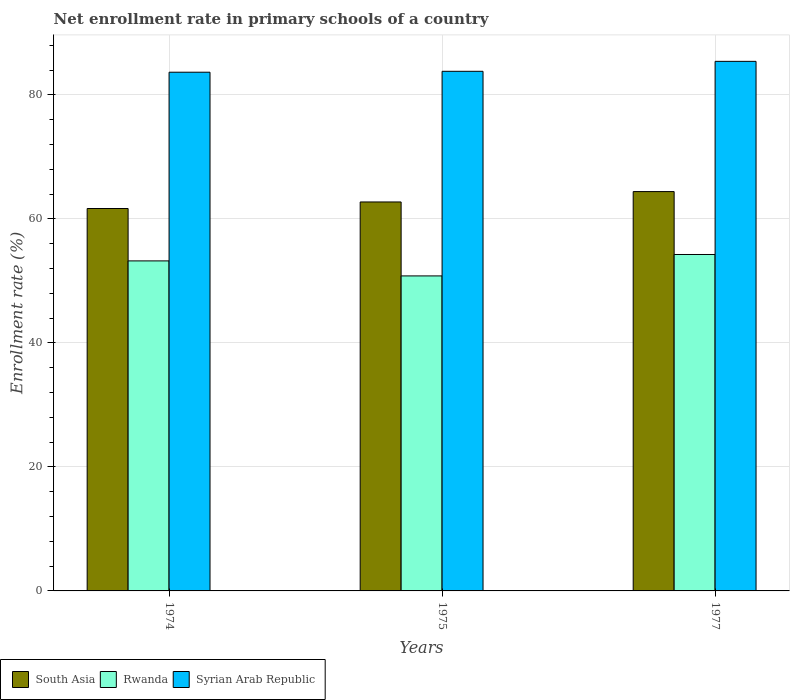How many groups of bars are there?
Offer a very short reply. 3. What is the label of the 2nd group of bars from the left?
Provide a short and direct response. 1975. In how many cases, is the number of bars for a given year not equal to the number of legend labels?
Ensure brevity in your answer.  0. What is the enrollment rate in primary schools in Syrian Arab Republic in 1974?
Your answer should be compact. 83.67. Across all years, what is the maximum enrollment rate in primary schools in Syrian Arab Republic?
Offer a terse response. 85.42. Across all years, what is the minimum enrollment rate in primary schools in Syrian Arab Republic?
Provide a succinct answer. 83.67. In which year was the enrollment rate in primary schools in Syrian Arab Republic minimum?
Your answer should be compact. 1974. What is the total enrollment rate in primary schools in Syrian Arab Republic in the graph?
Your response must be concise. 252.92. What is the difference between the enrollment rate in primary schools in Rwanda in 1974 and that in 1977?
Keep it short and to the point. -1.03. What is the difference between the enrollment rate in primary schools in South Asia in 1975 and the enrollment rate in primary schools in Syrian Arab Republic in 1974?
Offer a terse response. -20.93. What is the average enrollment rate in primary schools in South Asia per year?
Offer a very short reply. 62.95. In the year 1974, what is the difference between the enrollment rate in primary schools in Syrian Arab Republic and enrollment rate in primary schools in South Asia?
Offer a terse response. 21.99. What is the ratio of the enrollment rate in primary schools in Syrian Arab Republic in 1975 to that in 1977?
Provide a short and direct response. 0.98. Is the enrollment rate in primary schools in South Asia in 1974 less than that in 1977?
Give a very brief answer. Yes. What is the difference between the highest and the second highest enrollment rate in primary schools in South Asia?
Offer a very short reply. 1.67. What is the difference between the highest and the lowest enrollment rate in primary schools in Rwanda?
Make the answer very short. 3.46. Is the sum of the enrollment rate in primary schools in South Asia in 1974 and 1977 greater than the maximum enrollment rate in primary schools in Rwanda across all years?
Your answer should be compact. Yes. What does the 2nd bar from the left in 1977 represents?
Offer a very short reply. Rwanda. What does the 3rd bar from the right in 1975 represents?
Make the answer very short. South Asia. Is it the case that in every year, the sum of the enrollment rate in primary schools in South Asia and enrollment rate in primary schools in Rwanda is greater than the enrollment rate in primary schools in Syrian Arab Republic?
Give a very brief answer. Yes. Are all the bars in the graph horizontal?
Your answer should be very brief. No. How many years are there in the graph?
Keep it short and to the point. 3. Are the values on the major ticks of Y-axis written in scientific E-notation?
Offer a terse response. No. Does the graph contain grids?
Keep it short and to the point. Yes. Where does the legend appear in the graph?
Provide a succinct answer. Bottom left. How many legend labels are there?
Offer a terse response. 3. How are the legend labels stacked?
Your answer should be compact. Horizontal. What is the title of the graph?
Keep it short and to the point. Net enrollment rate in primary schools of a country. Does "Turkmenistan" appear as one of the legend labels in the graph?
Your response must be concise. No. What is the label or title of the X-axis?
Keep it short and to the point. Years. What is the label or title of the Y-axis?
Ensure brevity in your answer.  Enrollment rate (%). What is the Enrollment rate (%) in South Asia in 1974?
Your answer should be compact. 61.69. What is the Enrollment rate (%) in Rwanda in 1974?
Offer a terse response. 53.24. What is the Enrollment rate (%) of Syrian Arab Republic in 1974?
Ensure brevity in your answer.  83.67. What is the Enrollment rate (%) of South Asia in 1975?
Keep it short and to the point. 62.74. What is the Enrollment rate (%) in Rwanda in 1975?
Provide a succinct answer. 50.81. What is the Enrollment rate (%) in Syrian Arab Republic in 1975?
Keep it short and to the point. 83.82. What is the Enrollment rate (%) of South Asia in 1977?
Offer a very short reply. 64.42. What is the Enrollment rate (%) in Rwanda in 1977?
Give a very brief answer. 54.27. What is the Enrollment rate (%) of Syrian Arab Republic in 1977?
Provide a short and direct response. 85.42. Across all years, what is the maximum Enrollment rate (%) in South Asia?
Your answer should be compact. 64.42. Across all years, what is the maximum Enrollment rate (%) in Rwanda?
Offer a very short reply. 54.27. Across all years, what is the maximum Enrollment rate (%) of Syrian Arab Republic?
Your answer should be compact. 85.42. Across all years, what is the minimum Enrollment rate (%) in South Asia?
Your response must be concise. 61.69. Across all years, what is the minimum Enrollment rate (%) of Rwanda?
Keep it short and to the point. 50.81. Across all years, what is the minimum Enrollment rate (%) of Syrian Arab Republic?
Ensure brevity in your answer.  83.67. What is the total Enrollment rate (%) of South Asia in the graph?
Keep it short and to the point. 188.85. What is the total Enrollment rate (%) of Rwanda in the graph?
Your response must be concise. 158.32. What is the total Enrollment rate (%) in Syrian Arab Republic in the graph?
Your answer should be compact. 252.92. What is the difference between the Enrollment rate (%) of South Asia in 1974 and that in 1975?
Provide a short and direct response. -1.06. What is the difference between the Enrollment rate (%) of Rwanda in 1974 and that in 1975?
Your answer should be compact. 2.42. What is the difference between the Enrollment rate (%) in Syrian Arab Republic in 1974 and that in 1975?
Offer a terse response. -0.14. What is the difference between the Enrollment rate (%) of South Asia in 1974 and that in 1977?
Offer a very short reply. -2.73. What is the difference between the Enrollment rate (%) in Rwanda in 1974 and that in 1977?
Provide a succinct answer. -1.03. What is the difference between the Enrollment rate (%) in Syrian Arab Republic in 1974 and that in 1977?
Keep it short and to the point. -1.75. What is the difference between the Enrollment rate (%) of South Asia in 1975 and that in 1977?
Provide a succinct answer. -1.67. What is the difference between the Enrollment rate (%) of Rwanda in 1975 and that in 1977?
Offer a terse response. -3.46. What is the difference between the Enrollment rate (%) in Syrian Arab Republic in 1975 and that in 1977?
Your answer should be very brief. -1.61. What is the difference between the Enrollment rate (%) of South Asia in 1974 and the Enrollment rate (%) of Rwanda in 1975?
Offer a very short reply. 10.87. What is the difference between the Enrollment rate (%) of South Asia in 1974 and the Enrollment rate (%) of Syrian Arab Republic in 1975?
Offer a terse response. -22.13. What is the difference between the Enrollment rate (%) in Rwanda in 1974 and the Enrollment rate (%) in Syrian Arab Republic in 1975?
Make the answer very short. -30.58. What is the difference between the Enrollment rate (%) in South Asia in 1974 and the Enrollment rate (%) in Rwanda in 1977?
Make the answer very short. 7.42. What is the difference between the Enrollment rate (%) in South Asia in 1974 and the Enrollment rate (%) in Syrian Arab Republic in 1977?
Your answer should be compact. -23.74. What is the difference between the Enrollment rate (%) of Rwanda in 1974 and the Enrollment rate (%) of Syrian Arab Republic in 1977?
Provide a short and direct response. -32.19. What is the difference between the Enrollment rate (%) in South Asia in 1975 and the Enrollment rate (%) in Rwanda in 1977?
Provide a succinct answer. 8.47. What is the difference between the Enrollment rate (%) of South Asia in 1975 and the Enrollment rate (%) of Syrian Arab Republic in 1977?
Offer a terse response. -22.68. What is the difference between the Enrollment rate (%) in Rwanda in 1975 and the Enrollment rate (%) in Syrian Arab Republic in 1977?
Your answer should be compact. -34.61. What is the average Enrollment rate (%) in South Asia per year?
Make the answer very short. 62.95. What is the average Enrollment rate (%) in Rwanda per year?
Your response must be concise. 52.77. What is the average Enrollment rate (%) of Syrian Arab Republic per year?
Provide a succinct answer. 84.31. In the year 1974, what is the difference between the Enrollment rate (%) of South Asia and Enrollment rate (%) of Rwanda?
Provide a succinct answer. 8.45. In the year 1974, what is the difference between the Enrollment rate (%) of South Asia and Enrollment rate (%) of Syrian Arab Republic?
Offer a very short reply. -21.99. In the year 1974, what is the difference between the Enrollment rate (%) in Rwanda and Enrollment rate (%) in Syrian Arab Republic?
Provide a succinct answer. -30.44. In the year 1975, what is the difference between the Enrollment rate (%) in South Asia and Enrollment rate (%) in Rwanda?
Your response must be concise. 11.93. In the year 1975, what is the difference between the Enrollment rate (%) of South Asia and Enrollment rate (%) of Syrian Arab Republic?
Keep it short and to the point. -21.07. In the year 1975, what is the difference between the Enrollment rate (%) in Rwanda and Enrollment rate (%) in Syrian Arab Republic?
Keep it short and to the point. -33.01. In the year 1977, what is the difference between the Enrollment rate (%) in South Asia and Enrollment rate (%) in Rwanda?
Your response must be concise. 10.15. In the year 1977, what is the difference between the Enrollment rate (%) of South Asia and Enrollment rate (%) of Syrian Arab Republic?
Your answer should be very brief. -21.01. In the year 1977, what is the difference between the Enrollment rate (%) of Rwanda and Enrollment rate (%) of Syrian Arab Republic?
Offer a terse response. -31.16. What is the ratio of the Enrollment rate (%) in South Asia in 1974 to that in 1975?
Provide a short and direct response. 0.98. What is the ratio of the Enrollment rate (%) of Rwanda in 1974 to that in 1975?
Give a very brief answer. 1.05. What is the ratio of the Enrollment rate (%) of South Asia in 1974 to that in 1977?
Keep it short and to the point. 0.96. What is the ratio of the Enrollment rate (%) in Rwanda in 1974 to that in 1977?
Offer a terse response. 0.98. What is the ratio of the Enrollment rate (%) of Syrian Arab Republic in 1974 to that in 1977?
Keep it short and to the point. 0.98. What is the ratio of the Enrollment rate (%) of South Asia in 1975 to that in 1977?
Provide a short and direct response. 0.97. What is the ratio of the Enrollment rate (%) of Rwanda in 1975 to that in 1977?
Your answer should be compact. 0.94. What is the ratio of the Enrollment rate (%) of Syrian Arab Republic in 1975 to that in 1977?
Provide a short and direct response. 0.98. What is the difference between the highest and the second highest Enrollment rate (%) in South Asia?
Offer a terse response. 1.67. What is the difference between the highest and the second highest Enrollment rate (%) in Rwanda?
Make the answer very short. 1.03. What is the difference between the highest and the second highest Enrollment rate (%) in Syrian Arab Republic?
Your answer should be very brief. 1.61. What is the difference between the highest and the lowest Enrollment rate (%) of South Asia?
Provide a short and direct response. 2.73. What is the difference between the highest and the lowest Enrollment rate (%) in Rwanda?
Your answer should be compact. 3.46. What is the difference between the highest and the lowest Enrollment rate (%) of Syrian Arab Republic?
Your response must be concise. 1.75. 